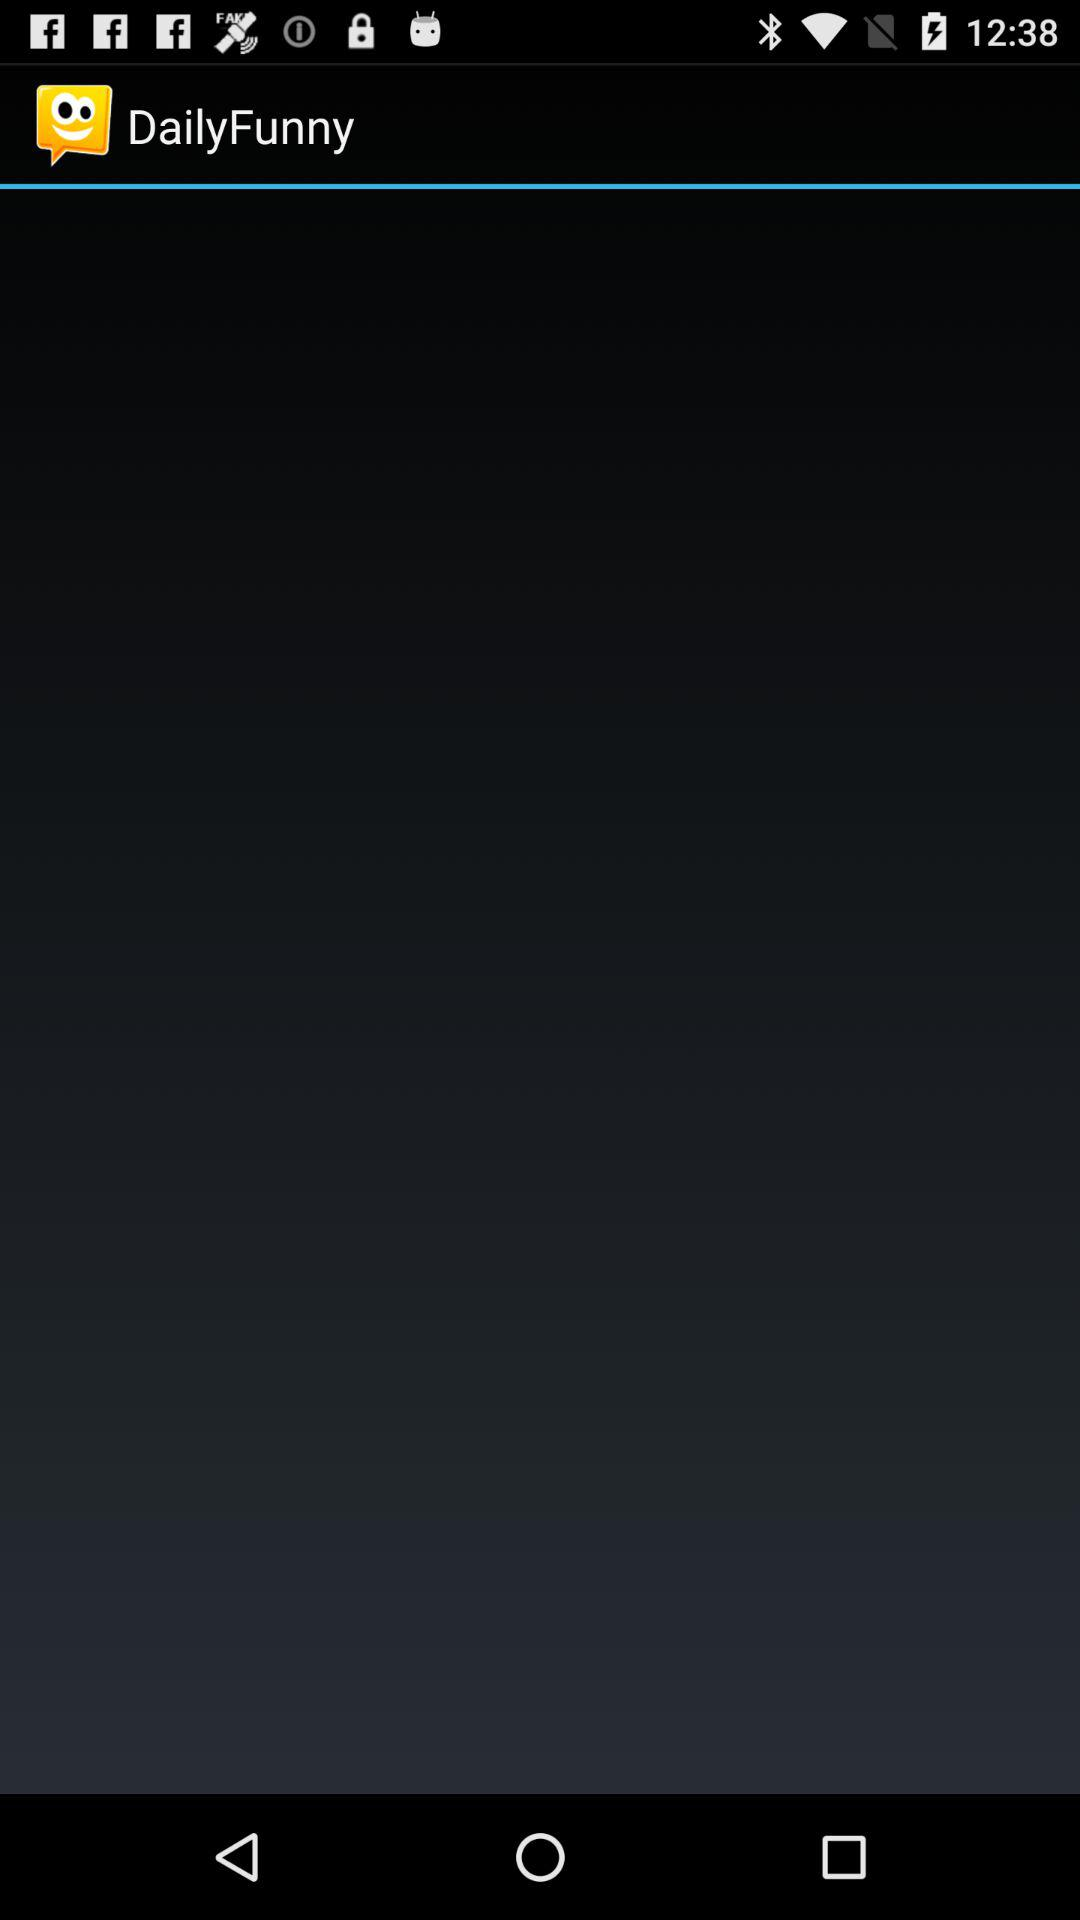What is the name of the application? The name of the application is "DailyFunny". 